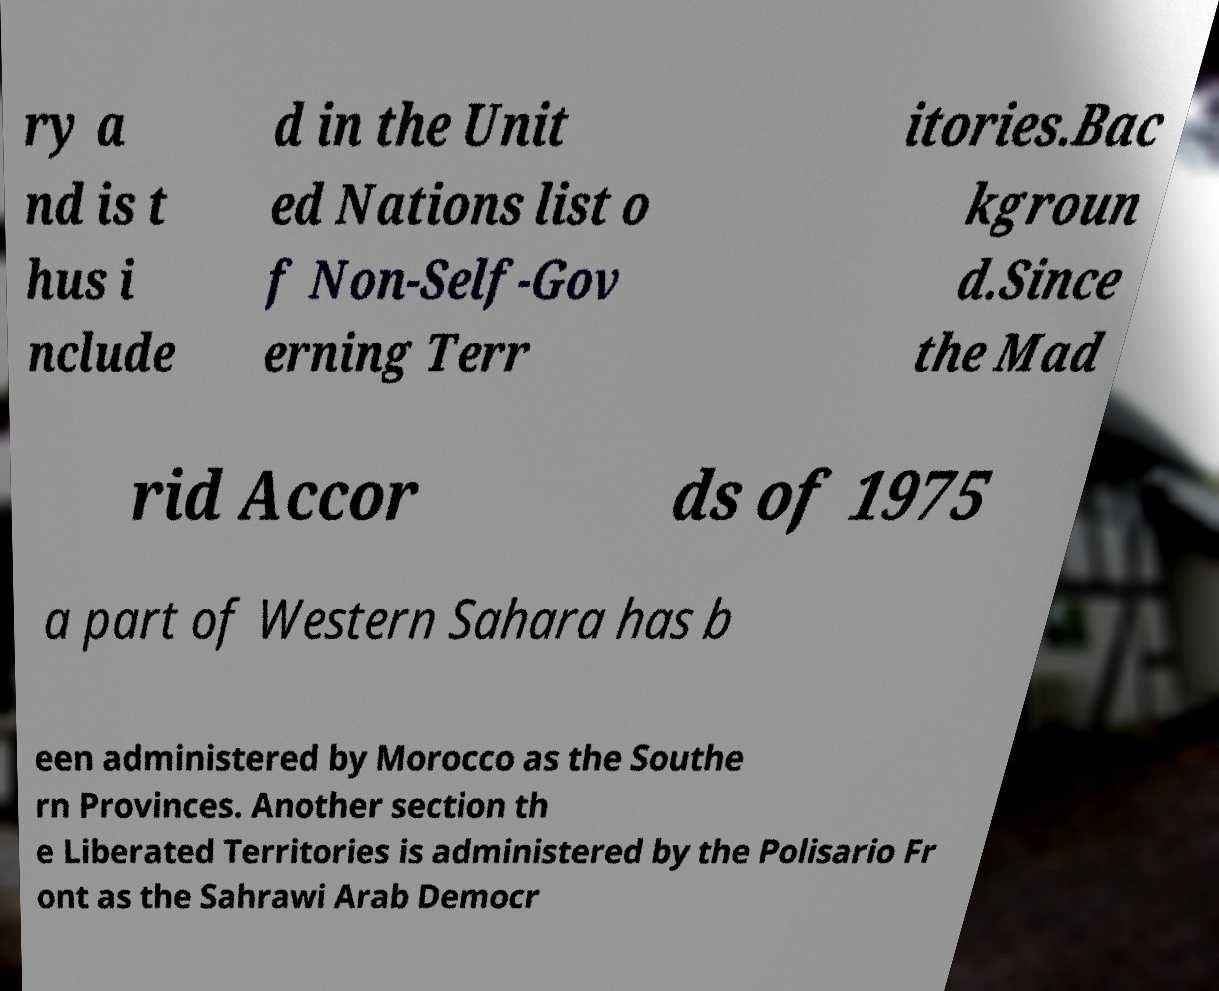There's text embedded in this image that I need extracted. Can you transcribe it verbatim? ry a nd is t hus i nclude d in the Unit ed Nations list o f Non-Self-Gov erning Terr itories.Bac kgroun d.Since the Mad rid Accor ds of 1975 a part of Western Sahara has b een administered by Morocco as the Southe rn Provinces. Another section th e Liberated Territories is administered by the Polisario Fr ont as the Sahrawi Arab Democr 